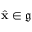<formula> <loc_0><loc_0><loc_500><loc_500>\hat { x } \in \mathfrak { g }</formula> 